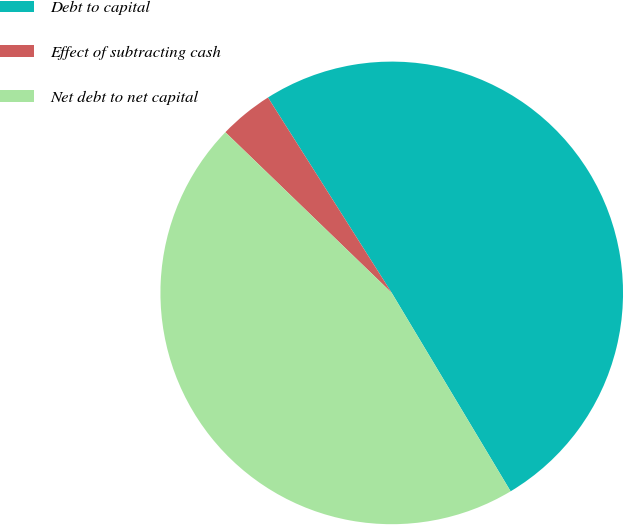Convert chart to OTSL. <chart><loc_0><loc_0><loc_500><loc_500><pie_chart><fcel>Debt to capital<fcel>Effect of subtracting cash<fcel>Net debt to net capital<nl><fcel>50.39%<fcel>3.79%<fcel>45.81%<nl></chart> 